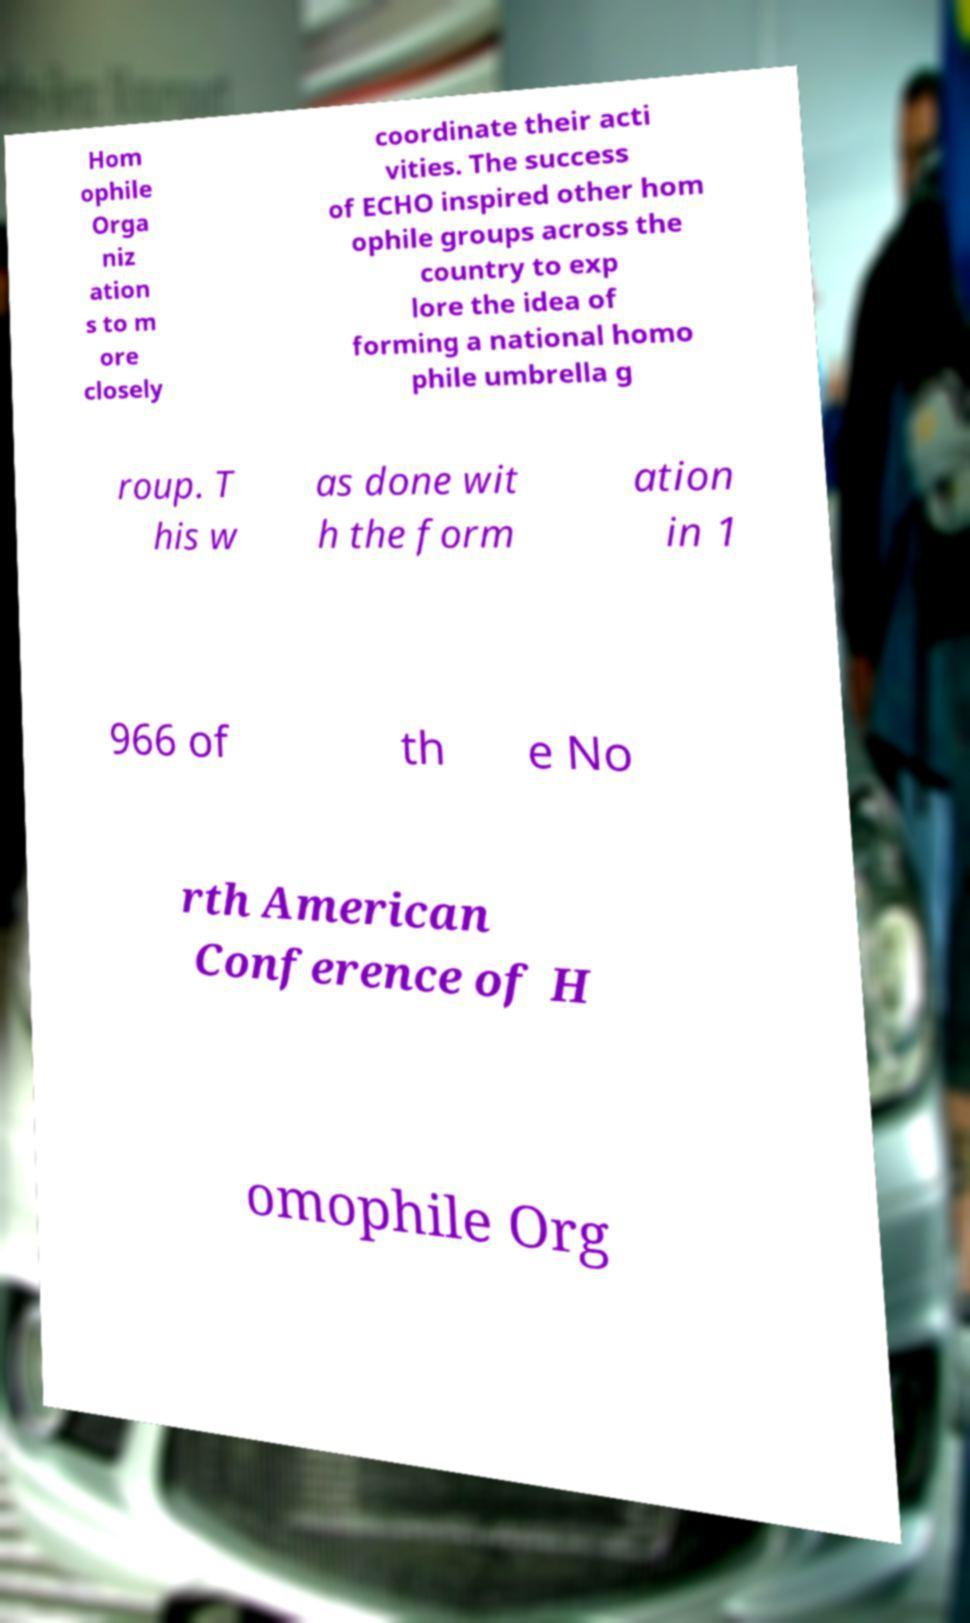Please read and relay the text visible in this image. What does it say? Hom ophile Orga niz ation s to m ore closely coordinate their acti vities. The success of ECHO inspired other hom ophile groups across the country to exp lore the idea of forming a national homo phile umbrella g roup. T his w as done wit h the form ation in 1 966 of th e No rth American Conference of H omophile Org 